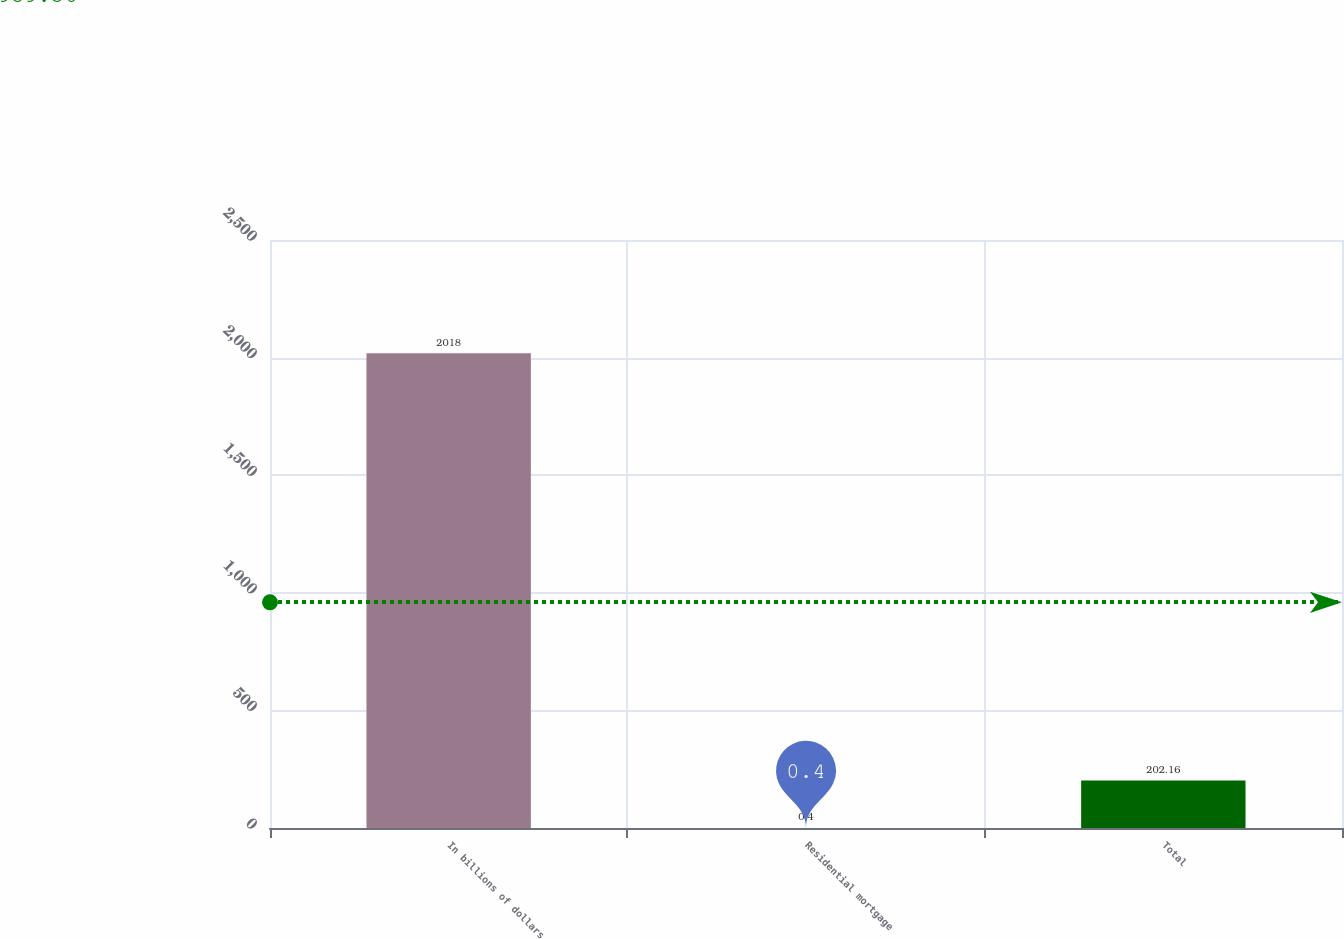Convert chart to OTSL. <chart><loc_0><loc_0><loc_500><loc_500><bar_chart><fcel>In billions of dollars<fcel>Residential mortgage<fcel>Total<nl><fcel>2018<fcel>0.4<fcel>202.16<nl></chart> 